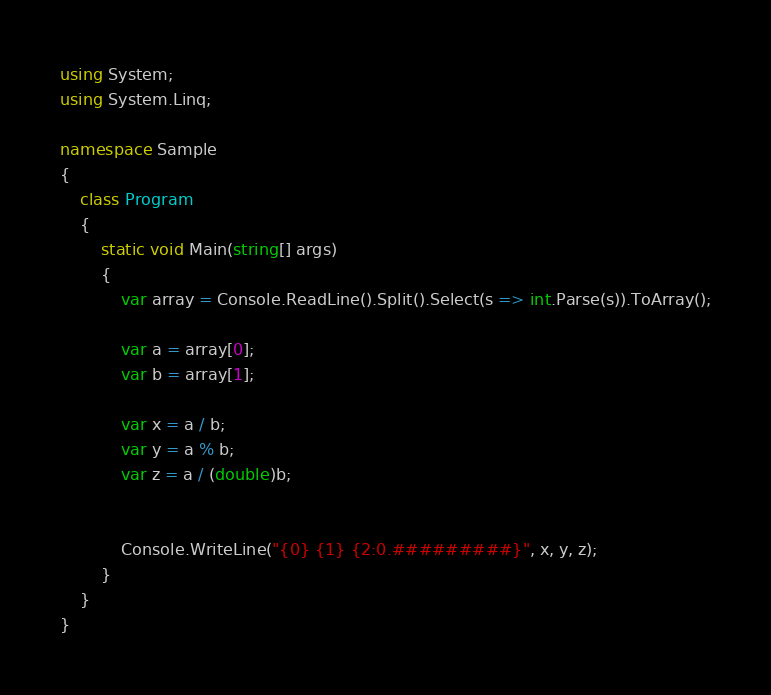Convert code to text. <code><loc_0><loc_0><loc_500><loc_500><_C#_>using System;
using System.Linq;

namespace Sample
{
	class Program
	{
		static void Main(string[] args)
		{
			var array = Console.ReadLine().Split().Select(s => int.Parse(s)).ToArray();

			var a = array[0];
			var b = array[1];

			var x = a / b;
			var y = a % b;
			var z = a / (double)b;


			Console.WriteLine("{0} {1} {2:0.#########}", x, y, z);
		}
	}
}

</code> 